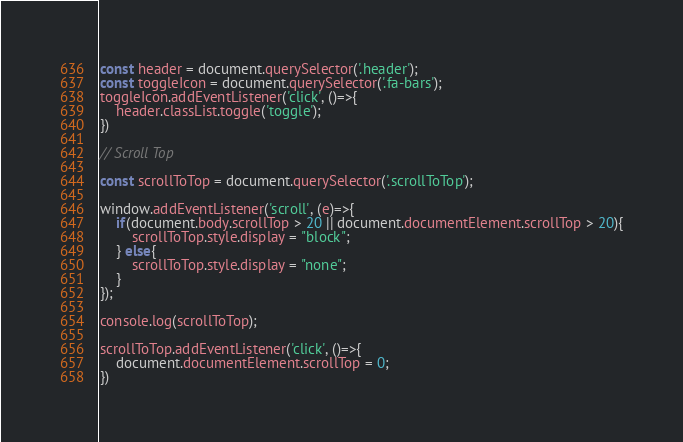<code> <loc_0><loc_0><loc_500><loc_500><_JavaScript_>const header = document.querySelector('.header');
const toggleIcon = document.querySelector('.fa-bars');
toggleIcon.addEventListener('click', ()=>{
    header.classList.toggle('toggle');
})

// Scroll Top

const scrollToTop = document.querySelector('.scrollToTop');

window.addEventListener('scroll', (e)=>{
    if(document.body.scrollTop > 20 || document.documentElement.scrollTop > 20){
        scrollToTop.style.display = "block";
    } else{
        scrollToTop.style.display = "none";
    }
});

console.log(scrollToTop);

scrollToTop.addEventListener('click', ()=>{
    document.documentElement.scrollTop = 0;
})
</code> 